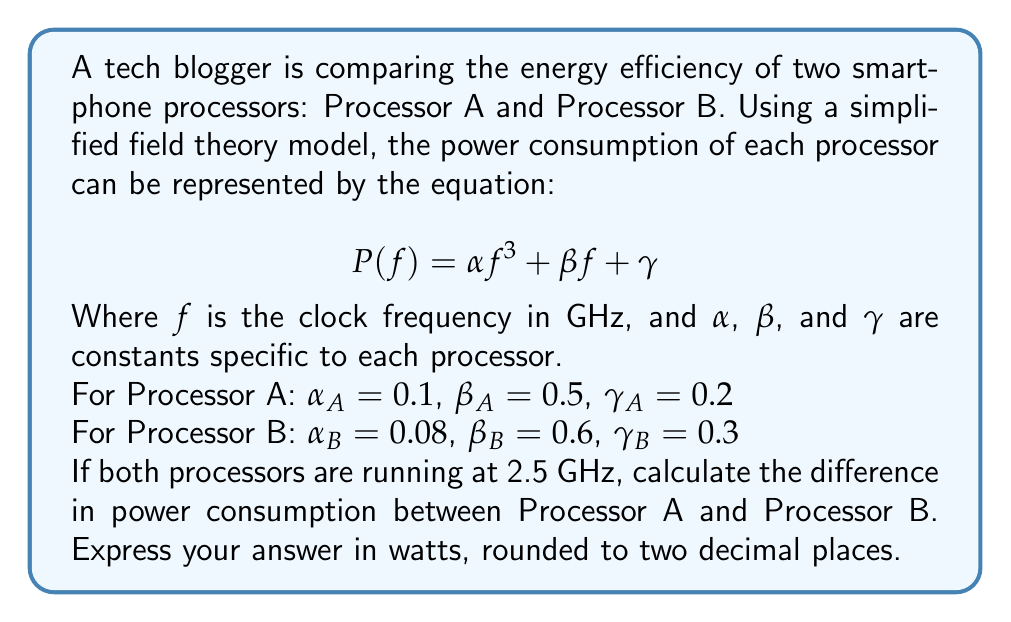Can you solve this math problem? To solve this problem, we need to follow these steps:

1. Calculate the power consumption for Processor A:
   $$P_A(2.5) = 0.1(2.5)^3 + 0.5(2.5) + 0.2$$
   
   $$P_A(2.5) = 0.1(15.625) + 1.25 + 0.2$$
   
   $$P_A(2.5) = 1.5625 + 1.25 + 0.2 = 3.0125\text{ W}$$

2. Calculate the power consumption for Processor B:
   $$P_B(2.5) = 0.08(2.5)^3 + 0.6(2.5) + 0.3$$
   
   $$P_B(2.5) = 0.08(15.625) + 1.5 + 0.3$$
   
   $$P_B(2.5) = 1.25 + 1.5 + 0.3 = 3.05\text{ W}$$

3. Calculate the difference in power consumption:
   $$\Delta P = P_A(2.5) - P_B(2.5)$$
   
   $$\Delta P = 3.0125 - 3.05 = -0.0375\text{ W}$$

4. Round the result to two decimal places:
   $$\Delta P \approx -0.04\text{ W}$$

The negative value indicates that Processor A consumes less power than Processor B at 2.5 GHz.
Answer: -0.04 W 